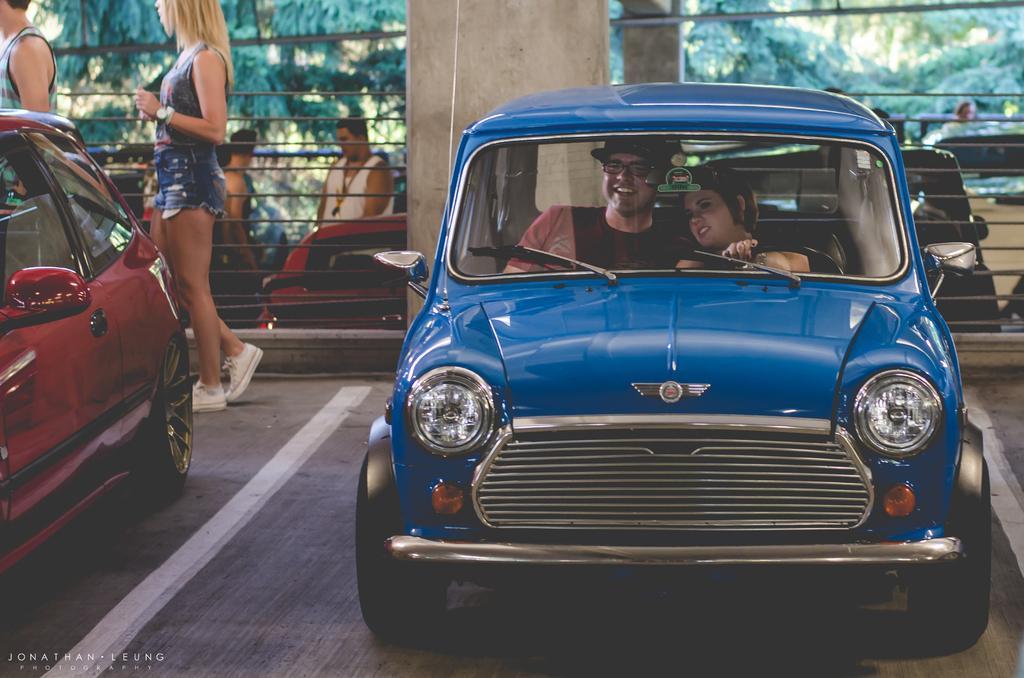Can you describe this image briefly? In the foreground of the image we can see two persons sitting inside a car placed on the ground. In the background, we can see a group of cars parked on the ground and a group of people standing on the ground, fence, a group of trees, pillars. At the bottom we can see some text. 